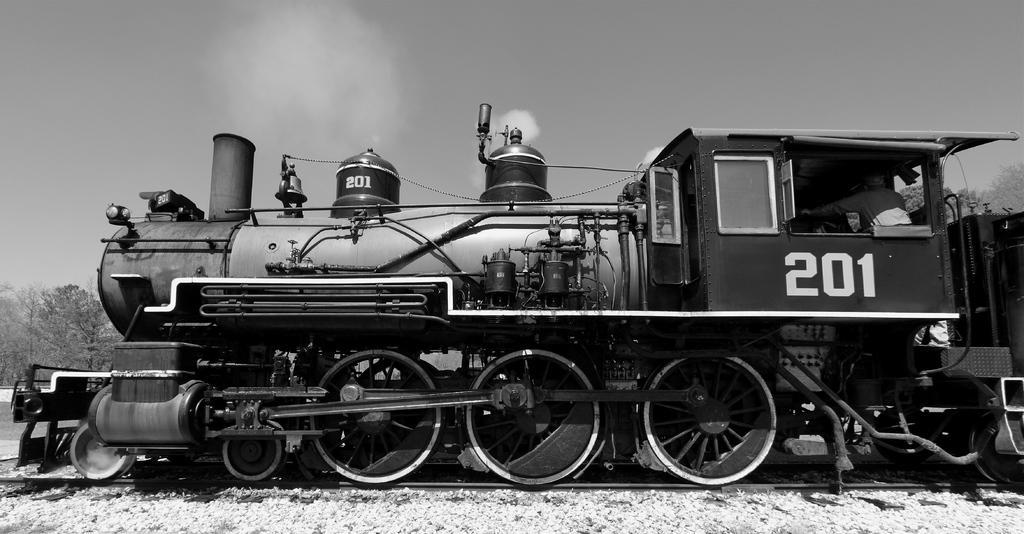In one or two sentences, can you explain what this image depicts? Here in this picture we can see train engine present on the railway track and we can also see person sitting in that and we can see the smoke released by the engine and beside that in the far we can see plants and trees present and we can see the sky is clear and this is a black and white image. 